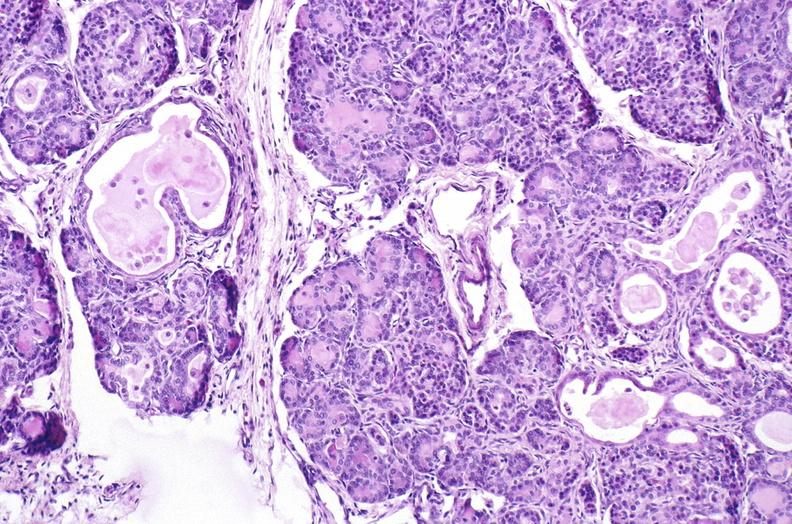does edema show cystic fibrosis?
Answer the question using a single word or phrase. No 